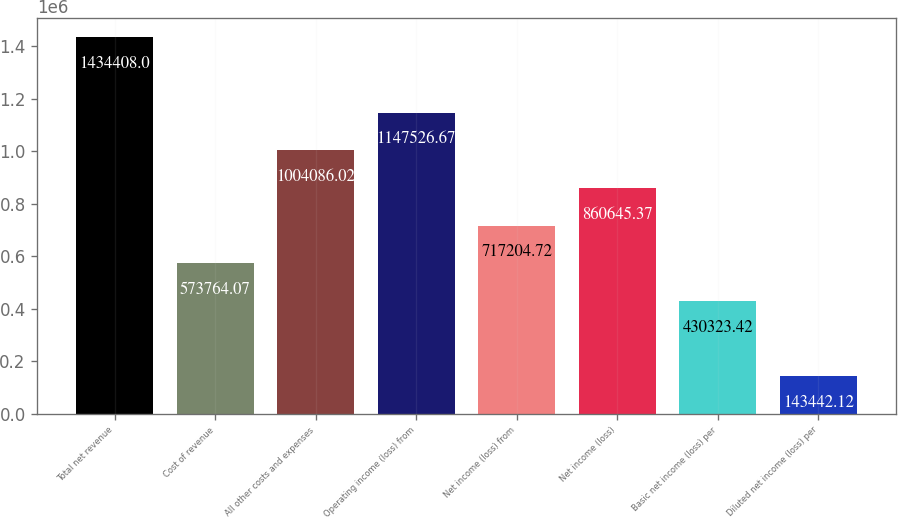Convert chart to OTSL. <chart><loc_0><loc_0><loc_500><loc_500><bar_chart><fcel>Total net revenue<fcel>Cost of revenue<fcel>All other costs and expenses<fcel>Operating income (loss) from<fcel>Net income (loss) from<fcel>Net income (loss)<fcel>Basic net income (loss) per<fcel>Diluted net income (loss) per<nl><fcel>1.43441e+06<fcel>573764<fcel>1.00409e+06<fcel>1.14753e+06<fcel>717205<fcel>860645<fcel>430323<fcel>143442<nl></chart> 